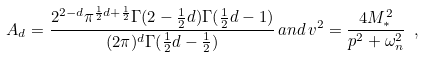Convert formula to latex. <formula><loc_0><loc_0><loc_500><loc_500>A _ { d } = \frac { 2 ^ { 2 - d } \pi ^ { \frac { 1 } { 2 } d + \frac { 1 } { 2 } } \Gamma ( 2 - \frac { 1 } { 2 } d ) \Gamma ( \frac { 1 } { 2 } d - 1 ) } { ( 2 \pi ) ^ { d } \Gamma ( \frac { 1 } { 2 } d - \frac { 1 } { 2 } ) } \, a n d \, v ^ { 2 } = \frac { 4 M _ { \ast } ^ { 2 } } { p ^ { 2 } + \omega _ { n } ^ { 2 } } \ ,</formula> 